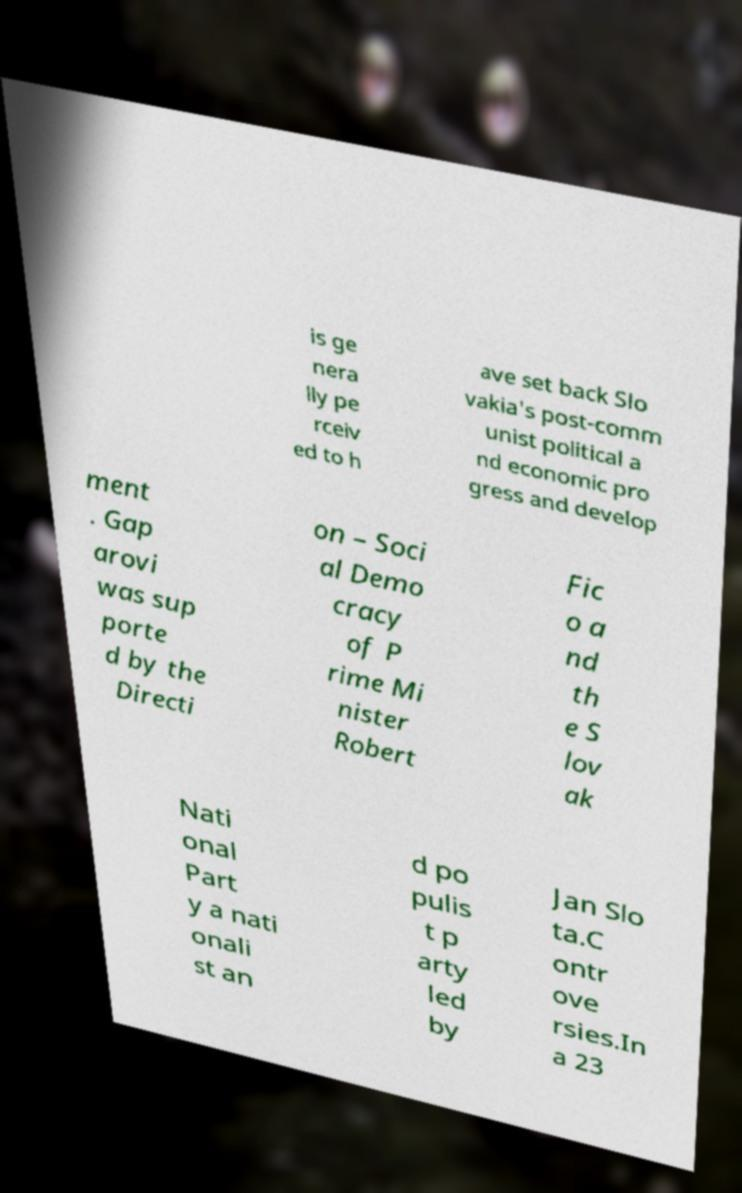Could you assist in decoding the text presented in this image and type it out clearly? is ge nera lly pe rceiv ed to h ave set back Slo vakia's post-comm unist political a nd economic pro gress and develop ment . Gap arovi was sup porte d by the Directi on – Soci al Demo cracy of P rime Mi nister Robert Fic o a nd th e S lov ak Nati onal Part y a nati onali st an d po pulis t p arty led by Jan Slo ta.C ontr ove rsies.In a 23 